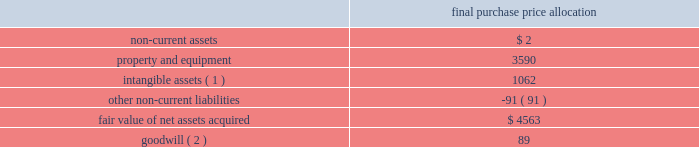American tower corporation and subsidiaries notes to consolidated financial statements the allocation of the purchase price was finalized during the year ended december 31 , 2012 .
The table summarizes the allocation of the aggregate purchase consideration paid and the amounts of assets acquired and liabilities assumed based upon their estimated fair value at the date of acquisition ( in thousands ) : purchase price allocation .
( 1 ) consists of customer-related intangibles of approximately $ 0.4 million and network location intangibles of approximately $ 0.7 million .
The customer-related intangibles and network location intangibles are being amortized on a straight-line basis over periods of up to 20 years .
( 2 ) the company expects that the goodwill recorded will be deductible for tax purposes .
The goodwill was allocated to the company 2019s international rental and management segment .
Colombia 2014colombia movil acquisition 2014on july 17 , 2011 , the company entered into a definitive agreement with colombia movil s.a .
E.s.p .
( 201ccolombia movil 201d ) , whereby atc sitios infraco , s.a.s. , a colombian subsidiary of the company ( 201catc infraco 201d ) , would purchase up to 2126 communications sites from colombia movil for an aggregate purchase price of approximately $ 182.0 million .
From december 21 , 2011 through the year ended december 31 , 2012 , atc infraco completed the purchase of 1526 communications sites for an aggregate purchase price of $ 136.2 million ( including contingent consideration of $ 17.3 million ) , subject to post-closing adjustments .
Through a subsidiary , millicom international cellular s.a .
( 201cmillicom 201d ) exercised its option to acquire an indirect , substantial non-controlling interest in atc infraco .
Under the terms of the agreement , the company is required to make additional payments upon the conversion of certain barter agreements with other wireless carriers to cash paying lease agreements .
Based on the company 2019s current estimates , the value of potential contingent consideration payments required to be made under the amended agreement is expected to be between zero and $ 32.8 million and is estimated to be $ 17.3 million using a probability weighted average of the expected outcomes at december 31 , 2012 .
During the year ended december 31 , 2012 , the company recorded a reduction in fair value of $ 1.2 million , which is included in other operating expenses in the consolidated statements of operations. .
Based on the final purchase price allocation what was the ratio of the property and equipment to the intangible assets? 
Computations: (3590 / 1062)
Answer: 3.38041. 